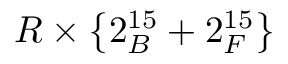<formula> <loc_0><loc_0><loc_500><loc_500>R \times \left \{ 2 _ { B } ^ { 1 5 } + 2 _ { F } ^ { 1 5 } \right \}</formula> 